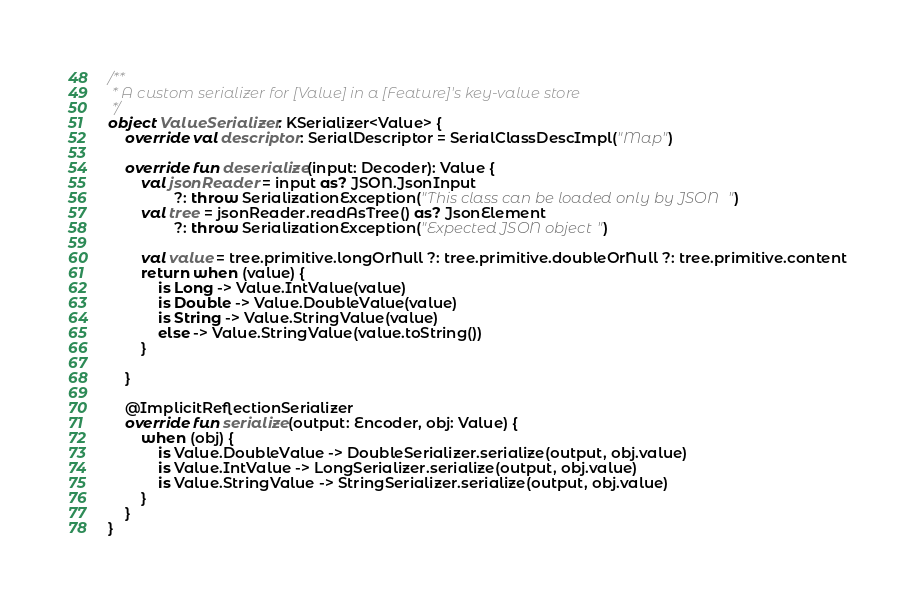<code> <loc_0><loc_0><loc_500><loc_500><_Kotlin_>
/**
 * A custom serializer for [Value] in a [Feature]'s key-value store
 */
object ValueSerializer: KSerializer<Value> {
    override val descriptor: SerialDescriptor = SerialClassDescImpl("Map")

    override fun deserialize(input: Decoder): Value {
        val jsonReader = input as? JSON.JsonInput
                ?: throw SerializationException("This class can be loaded only by JSON")
        val tree = jsonReader.readAsTree() as? JsonElement
                ?: throw SerializationException("Expected JSON object")

        val value = tree.primitive.longOrNull ?: tree.primitive.doubleOrNull ?: tree.primitive.content
        return when (value) {
            is Long -> Value.IntValue(value)
            is Double -> Value.DoubleValue(value)
            is String -> Value.StringValue(value)
            else -> Value.StringValue(value.toString())
        }

    }

    @ImplicitReflectionSerializer
    override fun serialize(output: Encoder, obj: Value) {
        when (obj) {
            is Value.DoubleValue -> DoubleSerializer.serialize(output, obj.value)
            is Value.IntValue -> LongSerializer.serialize(output, obj.value)
            is Value.StringValue -> StringSerializer.serialize(output, obj.value)
        }
    }
}</code> 